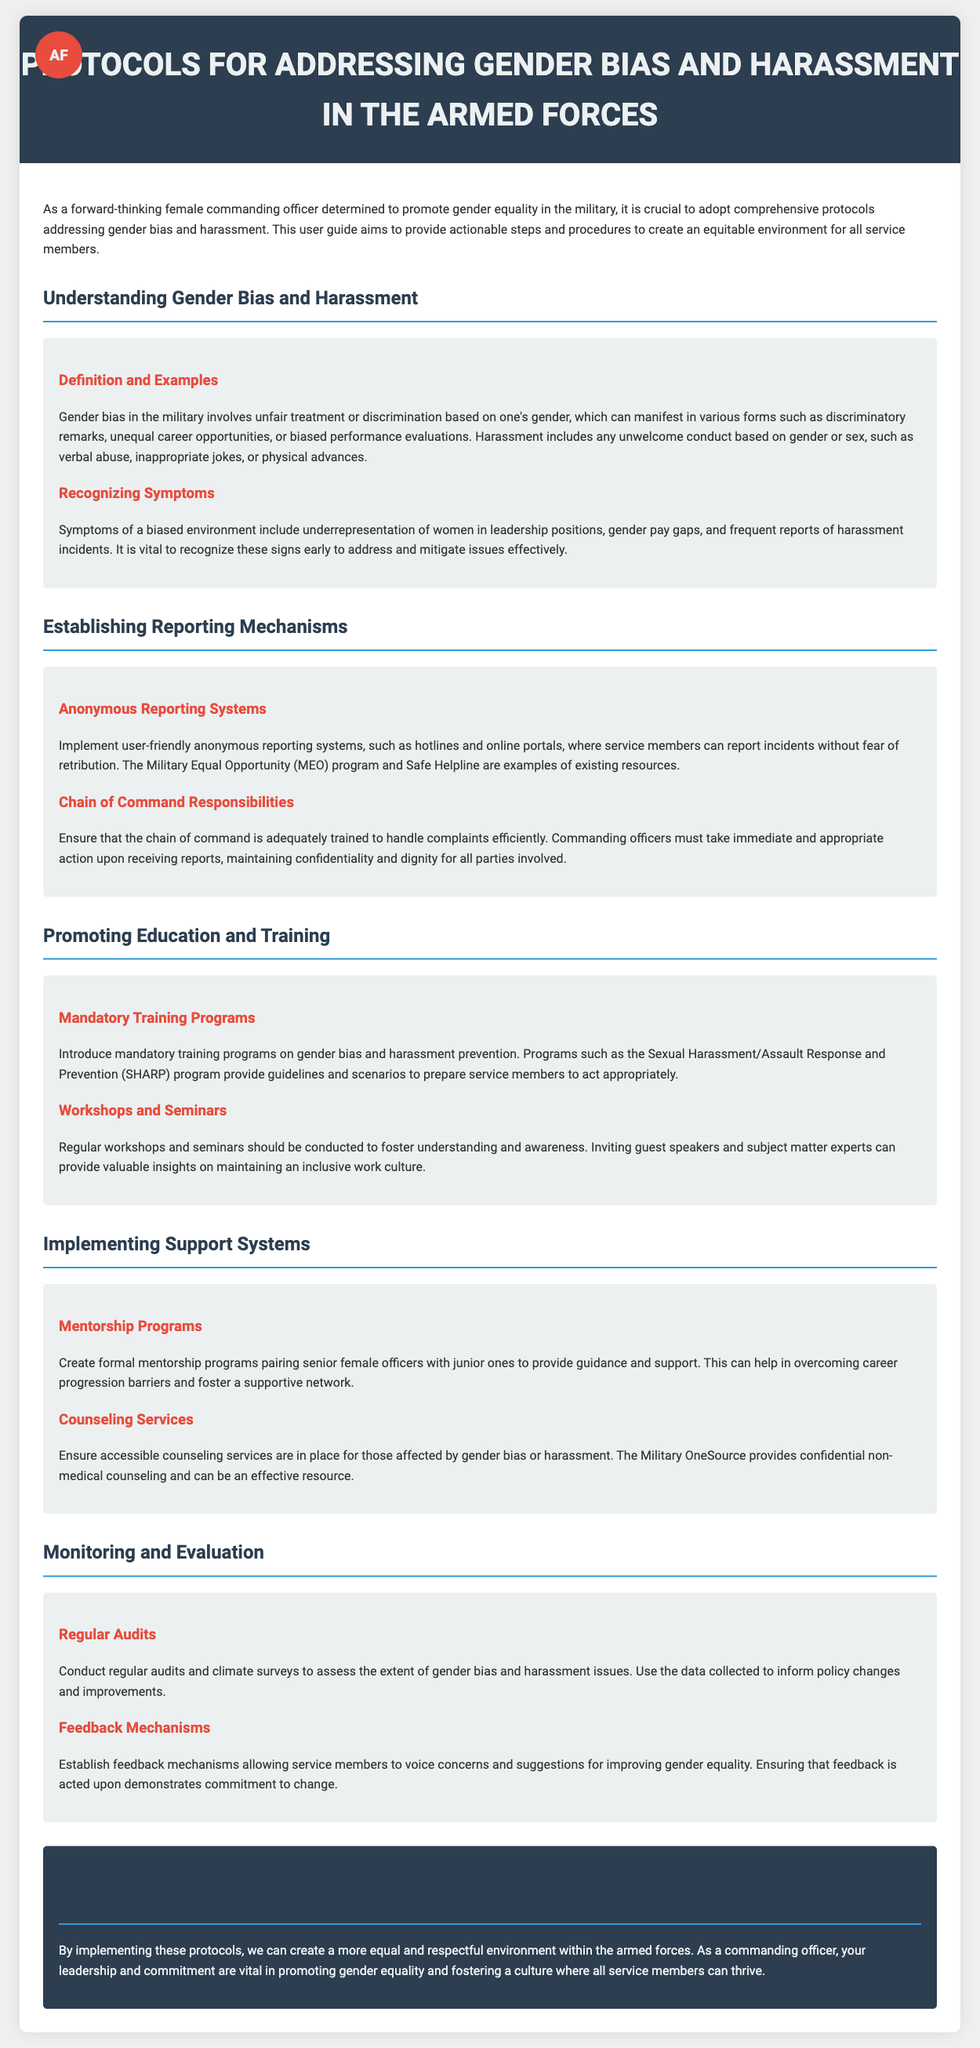What is the title of the document? The title of the document is stated in the header section, clearly indicating the subject matter.
Answer: Protocols for Addressing Gender Bias and Harassment in the Armed Forces What is one example of gender bias mentioned? The document lists discriminatory remarks as one of the forms of gender bias, along with unequal career opportunities and biased performance evaluations.
Answer: Discriminatory remarks What program is mentioned for anonymous reporting? The document specifies the Military Equal Opportunity program as an example of an existing resource for anonymous reporting.
Answer: Military Equal Opportunity (MEO) What is the goal of mentorship programs? The document describes the purpose of mentorship programs as helping to overcome career progression barriers and fostering a supportive network.
Answer: Overcoming career progression barriers Which training program is highlighted for prevention? The document mentions the Sexual Harassment/Assault Response and Prevention program as a mandatory training program for gender bias and harassment prevention.
Answer: Sexual Harassment/Assault Response and Prevention (SHARP) How often should audits be conducted? The document advises conducting regular audits and climate surveys to monitor gender bias and harassment issues.
Answer: Regularly What are counseling services intended for? The document states that counseling services are to provide support for those affected by gender bias or harassment.
Answer: Support for affected individuals What section discusses the importance of feedback mechanisms? The document specifies feedback mechanisms in the section concerning Monitoring and Evaluation, highlighting their role in improving gender equality.
Answer: Monitoring and Evaluation What is a symptom of a biased environment? The document identifies underrepresentation of women in leadership positions as a symptom of a biased environment.
Answer: Underrepresentation of women in leadership positions 